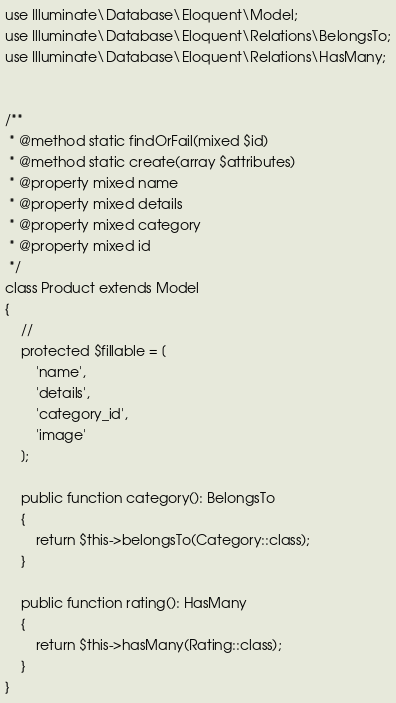Convert code to text. <code><loc_0><loc_0><loc_500><loc_500><_PHP_>
use Illuminate\Database\Eloquent\Model;
use Illuminate\Database\Eloquent\Relations\BelongsTo;
use Illuminate\Database\Eloquent\Relations\HasMany;


/**
 * @method static findOrFail(mixed $id)
 * @method static create(array $attributes)
 * @property mixed name
 * @property mixed details
 * @property mixed category
 * @property mixed id
 */
class Product extends Model
{
    //
    protected $fillable = [
        'name',
        'details',
        'category_id',
        'image'
    ];

    public function category(): BelongsTo
    {
        return $this->belongsTo(Category::class);
    }

    public function rating(): HasMany
    {
        return $this->hasMany(Rating::class);
    }
}
</code> 